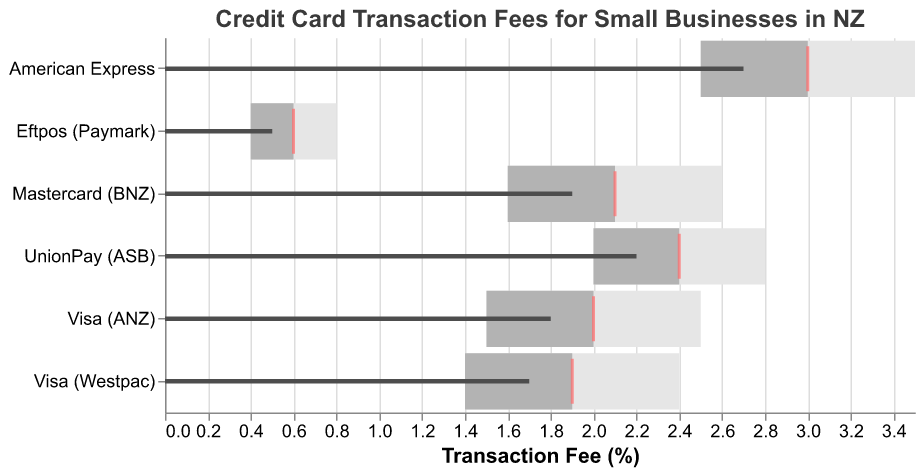What's the title of the chart? The title of the chart is usually displayed prominently at the top. In this case, the title is "Credit Card Transaction Fees for Small Businesses in NZ".
Answer: Credit Card Transaction Fees for Small Businesses in NZ Which card type has the highest actual transaction fee? By looking at the bars marked in a dark color, the highest value is for "American Express" with an actual fee of 2.7%.
Answer: American Express How does the fee for Eftpos (Paymark) compare to its comparative fee? Comparing the small tick marks (comparative) to the dark bar (actual), Eftpos (Paymark)'s comparative fee is 0.6%, which is higher than its actual fee of 0.5%.
Answer: Lower Which card type has the actual transaction fee closest to the comparative fee? Check the proximity between actual value bars and the comparative tick marks for each card type. "Visa (Westpac)" shows the closest values: actual 1.7% and comparative 1.9%.
Answer: Visa (Westpac) Are any actual fees outside their middle range? Look at the dark bars (actual) and compare them to their respective middle range (light grey bar). "American Express" (2.7) and "UnionPay (ASB)" (2.2) exceed their respective middle ranges.
Answer: Yes Which card type has the widest range for transaction fees? Check the difference between the smallest and largest values in the ranges. "American Express" has the widest range from 2.5% to 3.5%.
Answer: American Express What is the maximum comparative fee for card types? Look at all the comparative fees marked by red ticks. The highest is 3.0% for "American Express".
Answer: 3.0% How does Visa (ANZ) compare to Visa (Westpac) in terms of actual and comparative fees? Visa (ANZ) has an actual fee of 1.8% and a comparative fee of 2.0%. Visa (Westpac) has an actual fee of 1.7% and a comparative fee of 1.9%. Both actual and comparative fees for Visa (Westpac) are slightly lower.
Answer: Both are lower What is the range span for Mastercard (BNZ)? Check the range values for "Mastercard (BNZ)". The range is from 1.6% to 2.6%, creating a span of 1.0%.
Answer: 1.0% How many card types have their actual fees below 2%? Identify all bars with values below 2%. These are Visa (ANZ), Mastercard (BNZ), Eftpos (Paymark), and Visa (Westpac).
Answer: Four 